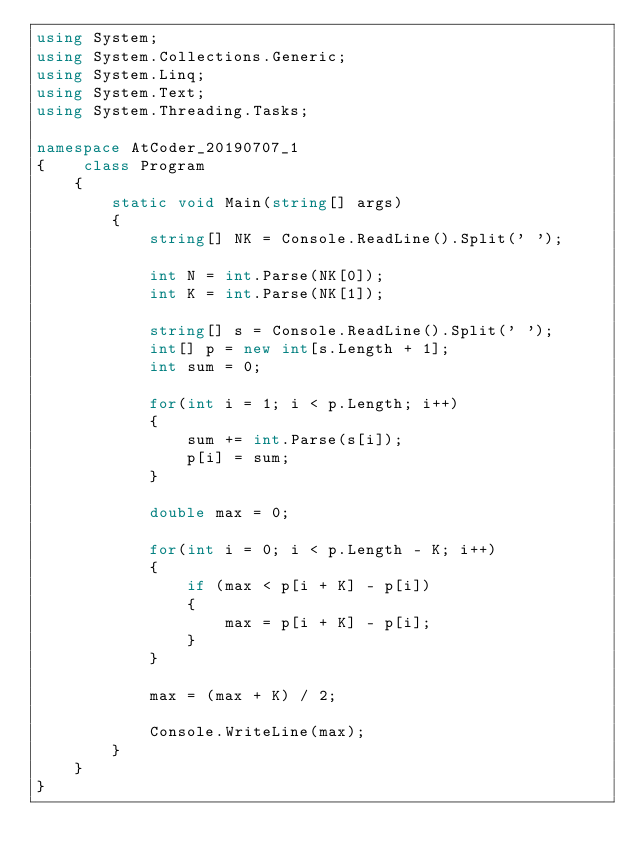Convert code to text. <code><loc_0><loc_0><loc_500><loc_500><_C#_>using System;
using System.Collections.Generic;
using System.Linq;
using System.Text;
using System.Threading.Tasks;

namespace AtCoder_20190707_1
{    class Program
    {
        static void Main(string[] args)
        {
            string[] NK = Console.ReadLine().Split(' ');

            int N = int.Parse(NK[0]);
            int K = int.Parse(NK[1]);

            string[] s = Console.ReadLine().Split(' ');
            int[] p = new int[s.Length + 1];
            int sum = 0;

            for(int i = 1; i < p.Length; i++)
            {
                sum += int.Parse(s[i]);
                p[i] = sum;
            }

            double max = 0;

            for(int i = 0; i < p.Length - K; i++)
            {
                if (max < p[i + K] - p[i])
                {
                    max = p[i + K] - p[i];
                }
            }

            max = (max + K) / 2;

            Console.WriteLine(max);
        }
    }
}</code> 